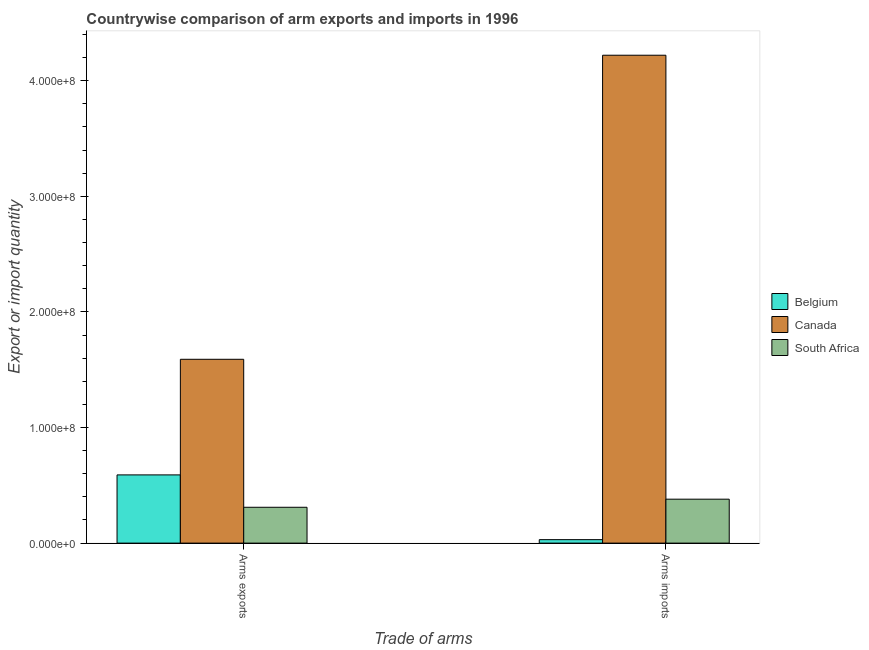How many groups of bars are there?
Provide a succinct answer. 2. Are the number of bars per tick equal to the number of legend labels?
Your answer should be very brief. Yes. What is the label of the 1st group of bars from the left?
Ensure brevity in your answer.  Arms exports. What is the arms imports in South Africa?
Offer a terse response. 3.80e+07. Across all countries, what is the maximum arms imports?
Your answer should be compact. 4.22e+08. Across all countries, what is the minimum arms exports?
Offer a very short reply. 3.10e+07. What is the total arms imports in the graph?
Make the answer very short. 4.63e+08. What is the difference between the arms exports in Belgium and that in Canada?
Your answer should be compact. -1.00e+08. What is the difference between the arms exports in Canada and the arms imports in South Africa?
Your response must be concise. 1.21e+08. What is the average arms exports per country?
Provide a short and direct response. 8.30e+07. What is the difference between the arms imports and arms exports in South Africa?
Your answer should be compact. 7.00e+06. What is the ratio of the arms imports in South Africa to that in Canada?
Offer a very short reply. 0.09. What does the 3rd bar from the left in Arms exports represents?
Provide a succinct answer. South Africa. What does the 1st bar from the right in Arms exports represents?
Offer a very short reply. South Africa. How many countries are there in the graph?
Offer a very short reply. 3. Does the graph contain grids?
Your answer should be compact. No. Where does the legend appear in the graph?
Give a very brief answer. Center right. How are the legend labels stacked?
Provide a short and direct response. Vertical. What is the title of the graph?
Make the answer very short. Countrywise comparison of arm exports and imports in 1996. Does "Guinea" appear as one of the legend labels in the graph?
Keep it short and to the point. No. What is the label or title of the X-axis?
Your answer should be compact. Trade of arms. What is the label or title of the Y-axis?
Your response must be concise. Export or import quantity. What is the Export or import quantity of Belgium in Arms exports?
Give a very brief answer. 5.90e+07. What is the Export or import quantity in Canada in Arms exports?
Your answer should be very brief. 1.59e+08. What is the Export or import quantity in South Africa in Arms exports?
Offer a terse response. 3.10e+07. What is the Export or import quantity in Belgium in Arms imports?
Keep it short and to the point. 3.00e+06. What is the Export or import quantity in Canada in Arms imports?
Provide a succinct answer. 4.22e+08. What is the Export or import quantity in South Africa in Arms imports?
Provide a short and direct response. 3.80e+07. Across all Trade of arms, what is the maximum Export or import quantity of Belgium?
Provide a short and direct response. 5.90e+07. Across all Trade of arms, what is the maximum Export or import quantity of Canada?
Your answer should be very brief. 4.22e+08. Across all Trade of arms, what is the maximum Export or import quantity in South Africa?
Keep it short and to the point. 3.80e+07. Across all Trade of arms, what is the minimum Export or import quantity of Canada?
Provide a short and direct response. 1.59e+08. Across all Trade of arms, what is the minimum Export or import quantity in South Africa?
Make the answer very short. 3.10e+07. What is the total Export or import quantity in Belgium in the graph?
Offer a very short reply. 6.20e+07. What is the total Export or import quantity of Canada in the graph?
Give a very brief answer. 5.81e+08. What is the total Export or import quantity in South Africa in the graph?
Your response must be concise. 6.90e+07. What is the difference between the Export or import quantity in Belgium in Arms exports and that in Arms imports?
Provide a succinct answer. 5.60e+07. What is the difference between the Export or import quantity of Canada in Arms exports and that in Arms imports?
Offer a terse response. -2.63e+08. What is the difference between the Export or import quantity in South Africa in Arms exports and that in Arms imports?
Offer a terse response. -7.00e+06. What is the difference between the Export or import quantity in Belgium in Arms exports and the Export or import quantity in Canada in Arms imports?
Offer a very short reply. -3.63e+08. What is the difference between the Export or import quantity of Belgium in Arms exports and the Export or import quantity of South Africa in Arms imports?
Ensure brevity in your answer.  2.10e+07. What is the difference between the Export or import quantity of Canada in Arms exports and the Export or import quantity of South Africa in Arms imports?
Your answer should be very brief. 1.21e+08. What is the average Export or import quantity of Belgium per Trade of arms?
Offer a terse response. 3.10e+07. What is the average Export or import quantity in Canada per Trade of arms?
Offer a very short reply. 2.90e+08. What is the average Export or import quantity of South Africa per Trade of arms?
Make the answer very short. 3.45e+07. What is the difference between the Export or import quantity of Belgium and Export or import quantity of Canada in Arms exports?
Ensure brevity in your answer.  -1.00e+08. What is the difference between the Export or import quantity of Belgium and Export or import quantity of South Africa in Arms exports?
Ensure brevity in your answer.  2.80e+07. What is the difference between the Export or import quantity in Canada and Export or import quantity in South Africa in Arms exports?
Your answer should be compact. 1.28e+08. What is the difference between the Export or import quantity of Belgium and Export or import quantity of Canada in Arms imports?
Provide a short and direct response. -4.19e+08. What is the difference between the Export or import quantity in Belgium and Export or import quantity in South Africa in Arms imports?
Your answer should be compact. -3.50e+07. What is the difference between the Export or import quantity in Canada and Export or import quantity in South Africa in Arms imports?
Make the answer very short. 3.84e+08. What is the ratio of the Export or import quantity of Belgium in Arms exports to that in Arms imports?
Ensure brevity in your answer.  19.67. What is the ratio of the Export or import quantity of Canada in Arms exports to that in Arms imports?
Offer a terse response. 0.38. What is the ratio of the Export or import quantity in South Africa in Arms exports to that in Arms imports?
Provide a succinct answer. 0.82. What is the difference between the highest and the second highest Export or import quantity in Belgium?
Offer a very short reply. 5.60e+07. What is the difference between the highest and the second highest Export or import quantity of Canada?
Provide a succinct answer. 2.63e+08. What is the difference between the highest and the second highest Export or import quantity in South Africa?
Your answer should be compact. 7.00e+06. What is the difference between the highest and the lowest Export or import quantity of Belgium?
Your answer should be very brief. 5.60e+07. What is the difference between the highest and the lowest Export or import quantity of Canada?
Keep it short and to the point. 2.63e+08. What is the difference between the highest and the lowest Export or import quantity in South Africa?
Ensure brevity in your answer.  7.00e+06. 